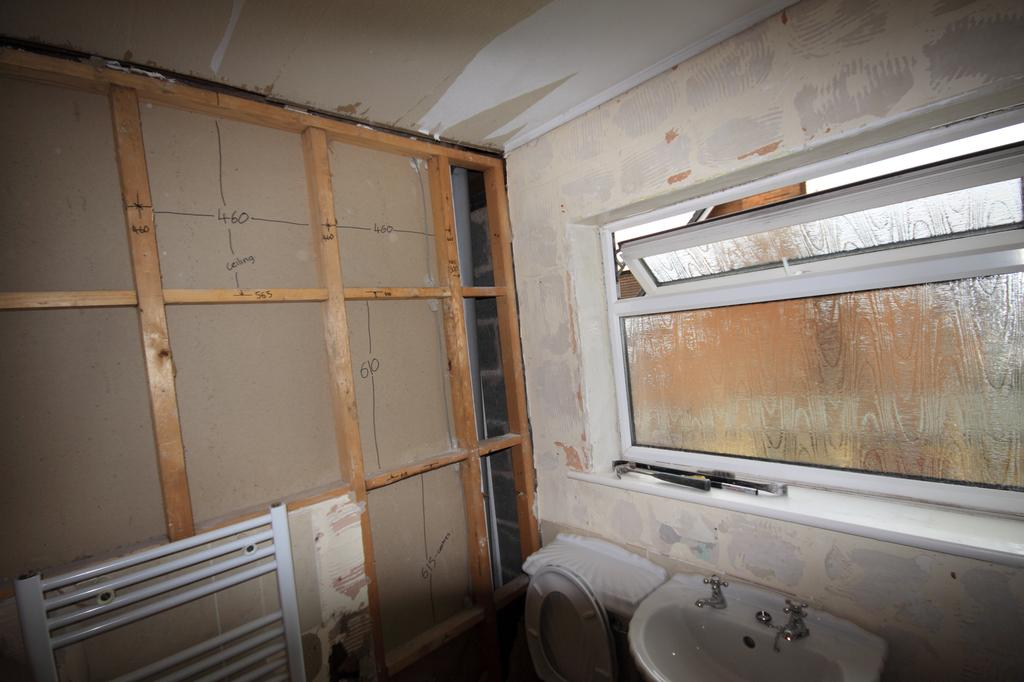What type of toilet is visible in the image? There is a flush toilet in the image. What other fixture is located near the flush toilet? There is a sink with two taps located beside the flush toilet. What can be seen above the sink in the image? There is a glass window above the sink. What color is the cap on the orange button in the image? There is no cap, orange, or button present in the image. 